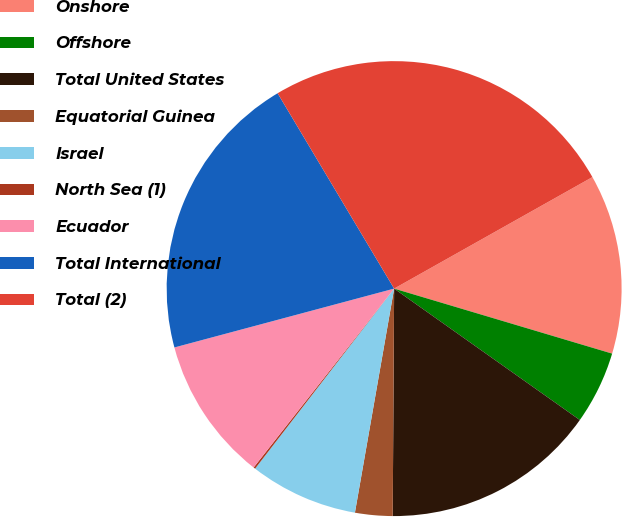<chart> <loc_0><loc_0><loc_500><loc_500><pie_chart><fcel>Onshore<fcel>Offshore<fcel>Total United States<fcel>Equatorial Guinea<fcel>Israel<fcel>North Sea (1)<fcel>Ecuador<fcel>Total International<fcel>Total (2)<nl><fcel>12.77%<fcel>5.19%<fcel>15.3%<fcel>2.66%<fcel>7.71%<fcel>0.13%<fcel>10.24%<fcel>20.61%<fcel>25.41%<nl></chart> 